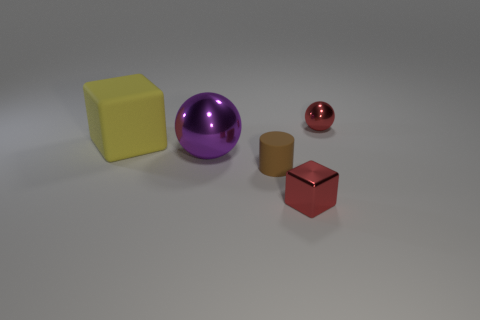There is a red thing in front of the tiny red shiny sphere that is to the right of the small metallic block; what shape is it?
Your response must be concise. Cube. There is a tiny brown matte thing; what shape is it?
Provide a short and direct response. Cylinder. How many spheres are right of the red shiny object that is behind the brown thing that is in front of the large yellow rubber thing?
Provide a short and direct response. 0. There is a tiny thing that is the same shape as the big rubber object; what color is it?
Give a very brief answer. Red. There is a red shiny thing to the left of the tiny thing that is behind the thing that is on the left side of the large purple object; what is its shape?
Your response must be concise. Cube. How big is the metal object that is both right of the tiny rubber cylinder and behind the metal block?
Your response must be concise. Small. Are there fewer purple balls than gray matte balls?
Keep it short and to the point. No. There is a red metal object that is in front of the brown rubber object; how big is it?
Keep it short and to the point. Small. There is a object that is to the right of the large matte block and behind the large purple metallic ball; what is its shape?
Ensure brevity in your answer.  Sphere. There is another thing that is the same shape as the large metallic object; what is its size?
Your response must be concise. Small. 